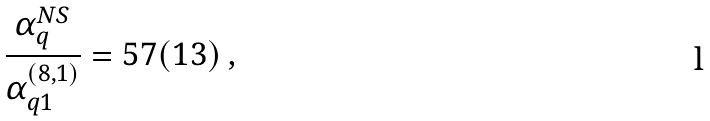Convert formula to latex. <formula><loc_0><loc_0><loc_500><loc_500>\frac { \alpha _ { q } ^ { N S } } { \alpha _ { q 1 } ^ { ( 8 , 1 ) } } = 5 7 ( 1 3 ) \ ,</formula> 